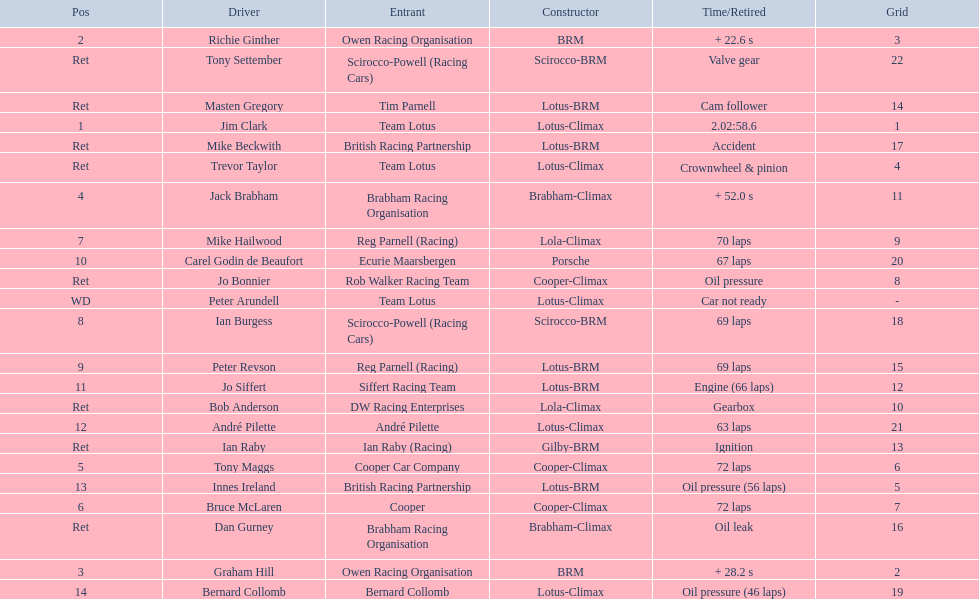Who are all the drivers? Jim Clark, Richie Ginther, Graham Hill, Jack Brabham, Tony Maggs, Bruce McLaren, Mike Hailwood, Ian Burgess, Peter Revson, Carel Godin de Beaufort, Jo Siffert, André Pilette, Innes Ireland, Bernard Collomb, Ian Raby, Dan Gurney, Mike Beckwith, Masten Gregory, Trevor Taylor, Jo Bonnier, Tony Settember, Bob Anderson, Peter Arundell. Which drove a cooper-climax? Tony Maggs, Bruce McLaren, Jo Bonnier. Of those, who was the top finisher? Tony Maggs. 